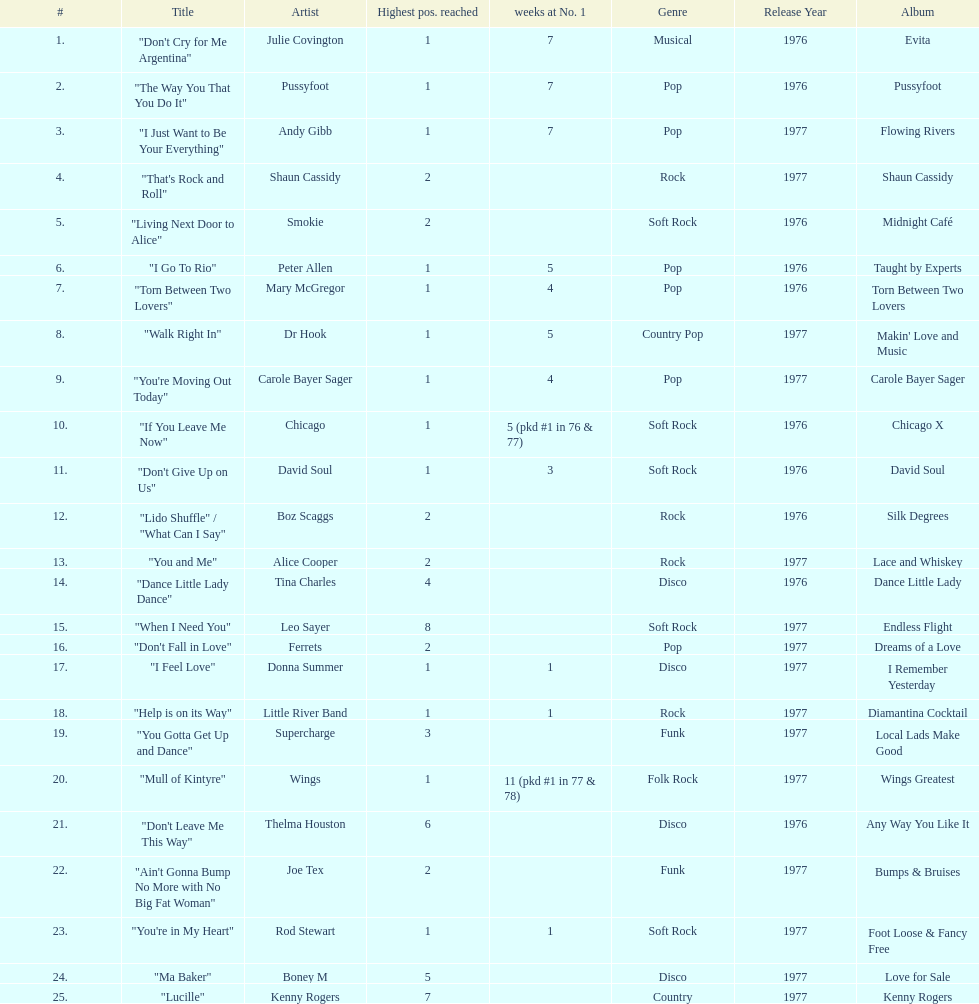Who had the most weeks at number one, according to the table? Wings. Could you help me parse every detail presented in this table? {'header': ['#', 'Title', 'Artist', 'Highest pos. reached', 'weeks at No. 1', 'Genre', 'Release Year', 'Album'], 'rows': [['1.', '"Don\'t Cry for Me Argentina"', 'Julie Covington', '1', '7', 'Musical', '1976', 'Evita'], ['2.', '"The Way You That You Do It"', 'Pussyfoot', '1', '7', 'Pop', '1976', 'Pussyfoot'], ['3.', '"I Just Want to Be Your Everything"', 'Andy Gibb', '1', '7', 'Pop', '1977', 'Flowing Rivers'], ['4.', '"That\'s Rock and Roll"', 'Shaun Cassidy', '2', '', 'Rock', '1977', 'Shaun Cassidy'], ['5.', '"Living Next Door to Alice"', 'Smokie', '2', '', 'Soft Rock', '1976', 'Midnight Café'], ['6.', '"I Go To Rio"', 'Peter Allen', '1', '5', 'Pop', '1976', 'Taught by Experts'], ['7.', '"Torn Between Two Lovers"', 'Mary McGregor', '1', '4', 'Pop', '1976', 'Torn Between Two Lovers'], ['8.', '"Walk Right In"', 'Dr Hook', '1', '5', 'Country Pop', '1977', "Makin' Love and Music"], ['9.', '"You\'re Moving Out Today"', 'Carole Bayer Sager', '1', '4', 'Pop', '1977', 'Carole Bayer Sager'], ['10.', '"If You Leave Me Now"', 'Chicago', '1', '5 (pkd #1 in 76 & 77)', 'Soft Rock', '1976', 'Chicago X'], ['11.', '"Don\'t Give Up on Us"', 'David Soul', '1', '3', 'Soft Rock', '1976', 'David Soul'], ['12.', '"Lido Shuffle" / "What Can I Say"', 'Boz Scaggs', '2', '', 'Rock', '1976', 'Silk Degrees'], ['13.', '"You and Me"', 'Alice Cooper', '2', '', 'Rock', '1977', 'Lace and Whiskey'], ['14.', '"Dance Little Lady Dance"', 'Tina Charles', '4', '', 'Disco', '1976', 'Dance Little Lady'], ['15.', '"When I Need You"', 'Leo Sayer', '8', '', 'Soft Rock', '1977', 'Endless Flight'], ['16.', '"Don\'t Fall in Love"', 'Ferrets', '2', '', 'Pop', '1977', 'Dreams of a Love'], ['17.', '"I Feel Love"', 'Donna Summer', '1', '1', 'Disco', '1977', 'I Remember Yesterday'], ['18.', '"Help is on its Way"', 'Little River Band', '1', '1', 'Rock', '1977', 'Diamantina Cocktail'], ['19.', '"You Gotta Get Up and Dance"', 'Supercharge', '3', '', 'Funk', '1977', 'Local Lads Make Good'], ['20.', '"Mull of Kintyre"', 'Wings', '1', '11 (pkd #1 in 77 & 78)', 'Folk Rock', '1977', 'Wings Greatest'], ['21.', '"Don\'t Leave Me This Way"', 'Thelma Houston', '6', '', 'Disco', '1976', 'Any Way You Like It'], ['22.', '"Ain\'t Gonna Bump No More with No Big Fat Woman"', 'Joe Tex', '2', '', 'Funk', '1977', 'Bumps & Bruises'], ['23.', '"You\'re in My Heart"', 'Rod Stewart', '1', '1', 'Soft Rock', '1977', 'Foot Loose & Fancy Free'], ['24.', '"Ma Baker"', 'Boney M', '5', '', 'Disco', '1977', 'Love for Sale'], ['25.', '"Lucille"', 'Kenny Rogers', '7', '', 'Country', '1977', 'Kenny Rogers']]} 